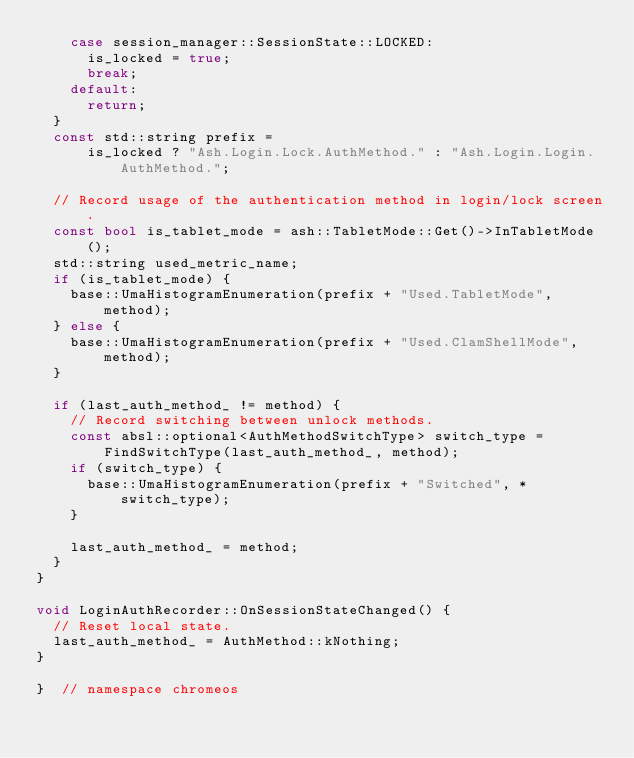<code> <loc_0><loc_0><loc_500><loc_500><_C++_>    case session_manager::SessionState::LOCKED:
      is_locked = true;
      break;
    default:
      return;
  }
  const std::string prefix =
      is_locked ? "Ash.Login.Lock.AuthMethod." : "Ash.Login.Login.AuthMethod.";

  // Record usage of the authentication method in login/lock screen.
  const bool is_tablet_mode = ash::TabletMode::Get()->InTabletMode();
  std::string used_metric_name;
  if (is_tablet_mode) {
    base::UmaHistogramEnumeration(prefix + "Used.TabletMode", method);
  } else {
    base::UmaHistogramEnumeration(prefix + "Used.ClamShellMode", method);
  }

  if (last_auth_method_ != method) {
    // Record switching between unlock methods.
    const absl::optional<AuthMethodSwitchType> switch_type =
        FindSwitchType(last_auth_method_, method);
    if (switch_type) {
      base::UmaHistogramEnumeration(prefix + "Switched", *switch_type);
    }

    last_auth_method_ = method;
  }
}

void LoginAuthRecorder::OnSessionStateChanged() {
  // Reset local state.
  last_auth_method_ = AuthMethod::kNothing;
}

}  // namespace chromeos
</code> 